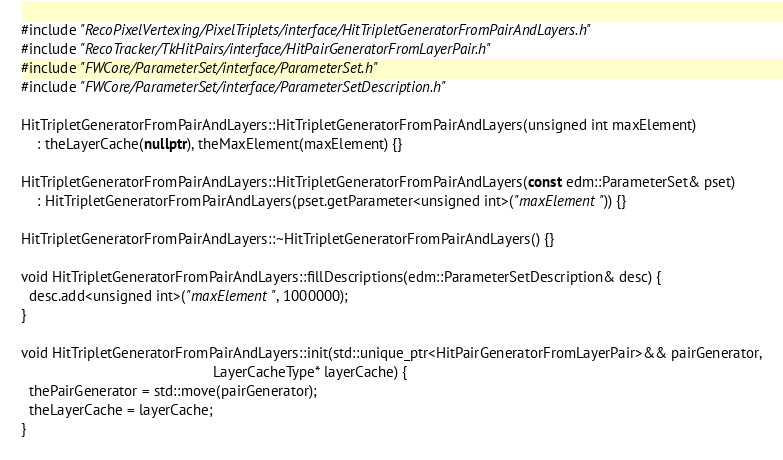<code> <loc_0><loc_0><loc_500><loc_500><_C++_>#include "RecoPixelVertexing/PixelTriplets/interface/HitTripletGeneratorFromPairAndLayers.h"
#include "RecoTracker/TkHitPairs/interface/HitPairGeneratorFromLayerPair.h"
#include "FWCore/ParameterSet/interface/ParameterSet.h"
#include "FWCore/ParameterSet/interface/ParameterSetDescription.h"

HitTripletGeneratorFromPairAndLayers::HitTripletGeneratorFromPairAndLayers(unsigned int maxElement)
    : theLayerCache(nullptr), theMaxElement(maxElement) {}

HitTripletGeneratorFromPairAndLayers::HitTripletGeneratorFromPairAndLayers(const edm::ParameterSet& pset)
    : HitTripletGeneratorFromPairAndLayers(pset.getParameter<unsigned int>("maxElement")) {}

HitTripletGeneratorFromPairAndLayers::~HitTripletGeneratorFromPairAndLayers() {}

void HitTripletGeneratorFromPairAndLayers::fillDescriptions(edm::ParameterSetDescription& desc) {
  desc.add<unsigned int>("maxElement", 1000000);
}

void HitTripletGeneratorFromPairAndLayers::init(std::unique_ptr<HitPairGeneratorFromLayerPair>&& pairGenerator,
                                                LayerCacheType* layerCache) {
  thePairGenerator = std::move(pairGenerator);
  theLayerCache = layerCache;
}
</code> 